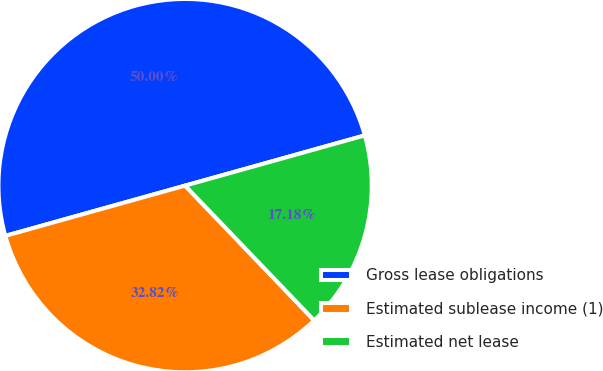<chart> <loc_0><loc_0><loc_500><loc_500><pie_chart><fcel>Gross lease obligations<fcel>Estimated sublease income (1)<fcel>Estimated net lease<nl><fcel>50.0%<fcel>32.82%<fcel>17.18%<nl></chart> 